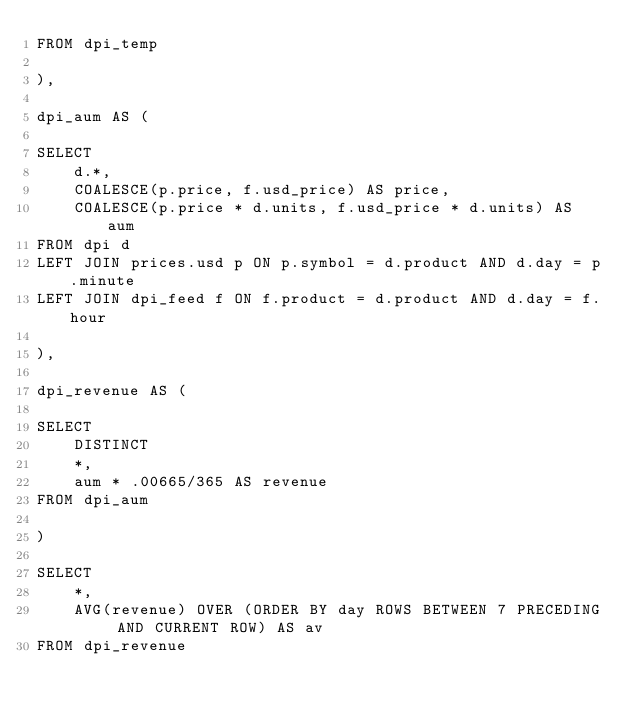Convert code to text. <code><loc_0><loc_0><loc_500><loc_500><_SQL_>FROM dpi_temp

),

dpi_aum AS (

SELECT
    d.*,
    COALESCE(p.price, f.usd_price) AS price,
    COALESCE(p.price * d.units, f.usd_price * d.units) AS aum
FROM dpi d
LEFT JOIN prices.usd p ON p.symbol = d.product AND d.day = p.minute
LEFT JOIN dpi_feed f ON f.product = d.product AND d.day = f.hour

),

dpi_revenue AS (

SELECT
    DISTINCT
    *,
    aum * .00665/365 AS revenue
FROM dpi_aum

)

SELECT 
    *,
    AVG(revenue) OVER (ORDER BY day ROWS BETWEEN 7 PRECEDING AND CURRENT ROW) AS av
FROM dpi_revenue</code> 